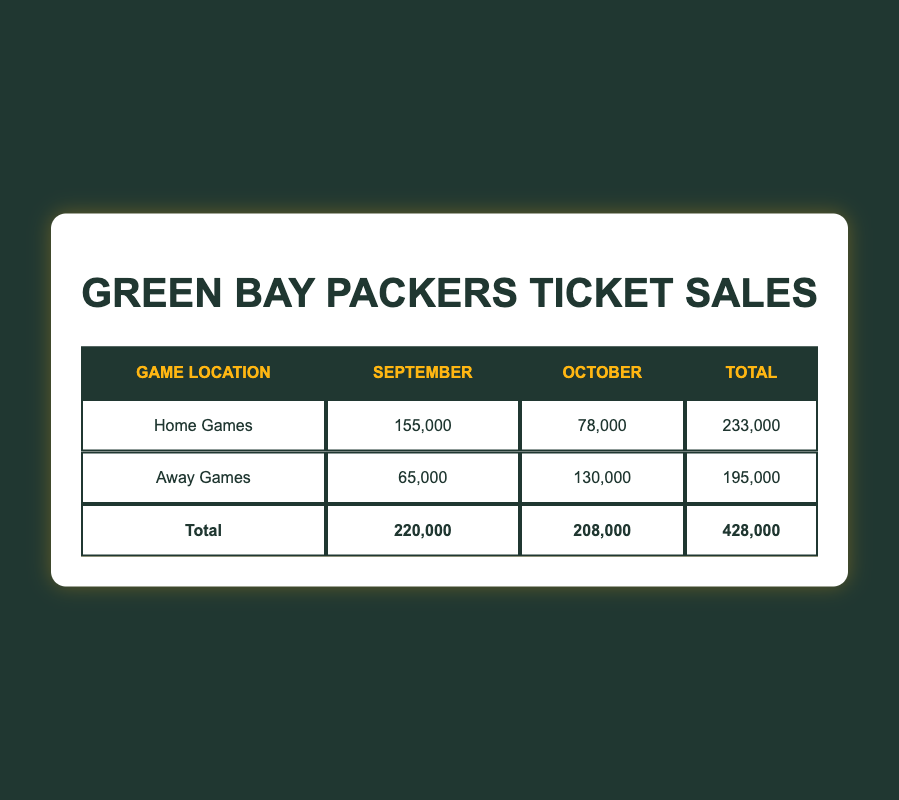What is the total number of tickets sold for home games in September? The table shows that for home games in September, the total is 155,000 tickets sold. This value is directly listed in the home games row under the September column.
Answer: 155,000 What is the total number of tickets sold for away games in October? The table indicates that for away games in October, the total is 130,000 tickets sold. This value can be found in the away games row under the October column.
Answer: 130,000 Did the Green Bay Packers sell more tickets for home games than away games overall? To determine this, we can compare the total tickets sold for home games (233,000) and away games (195,000) seen in the Total column of the respective rows. Since 233,000 is greater than 195,000, the answer is yes.
Answer: Yes What is the difference in total tickets sold between home and away games? The total for home games is 233,000, and for away games, it is 195,000. The difference can be calculated by subtracting the total for away games from that of home games: 233,000 - 195,000 equals 38,000. This calculation shows how many more tickets were sold for home games than away games.
Answer: 38,000 What is the average number of tickets sold per home game for September? There were two home games in September: one against the Chicago Bears (80,000 tickets) and one against the Minnesota Vikings (75,000 tickets). To find the average, first sum the tickets sold: 80,000 + 75,000 = 155,000. Then divide by the number of games (2): 155,000 / 2 = 77,500. The average number of tickets sold per home game in September is thus calculated.
Answer: 77,500 